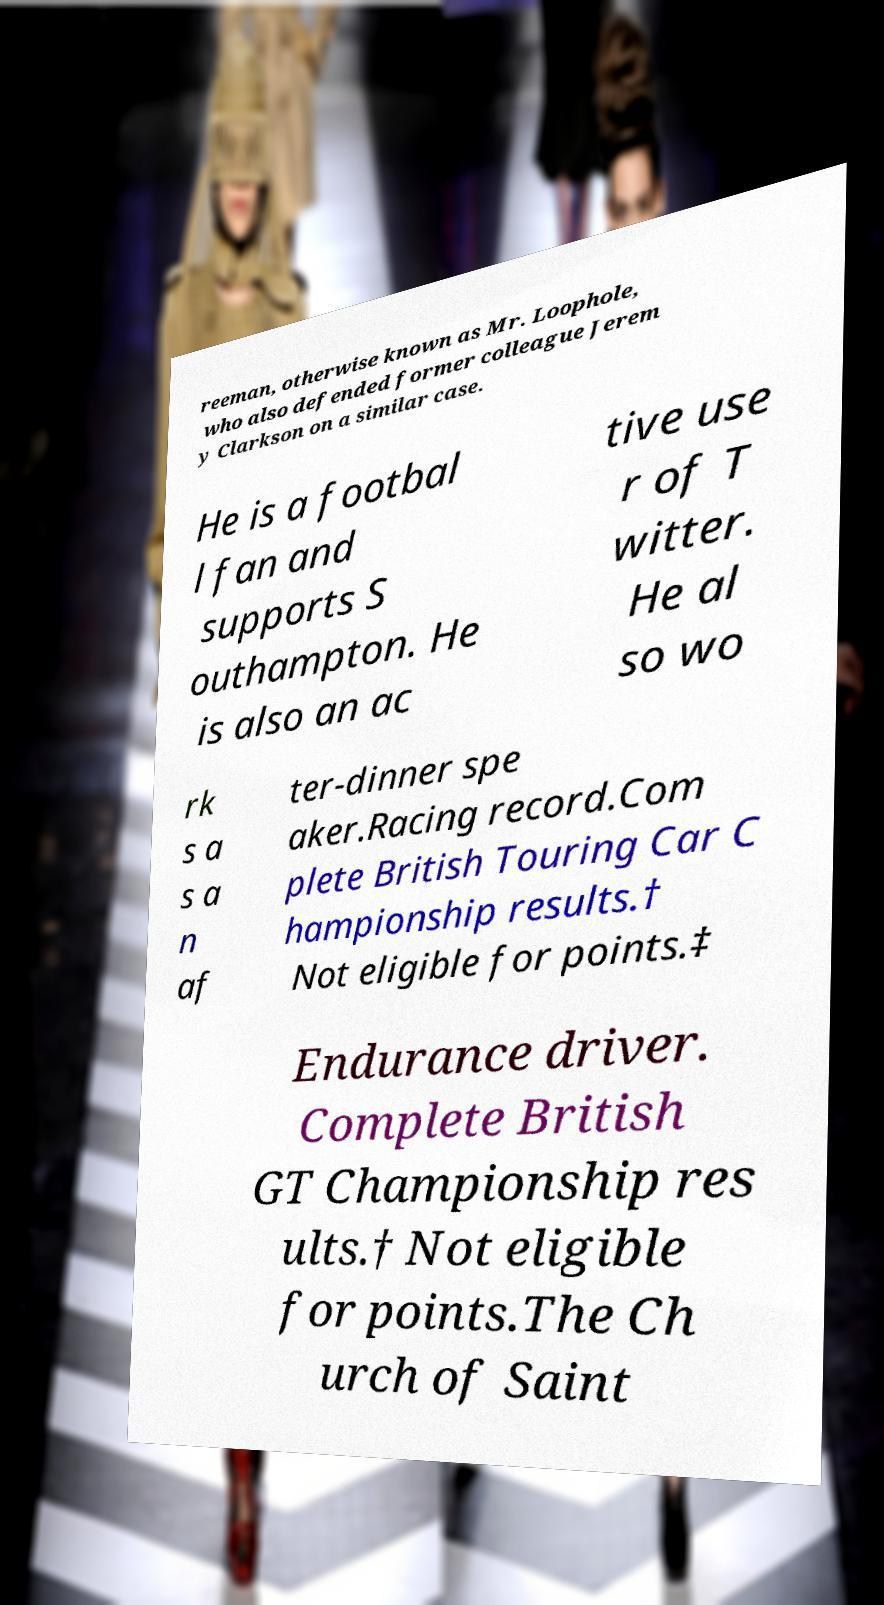For documentation purposes, I need the text within this image transcribed. Could you provide that? reeman, otherwise known as Mr. Loophole, who also defended former colleague Jerem y Clarkson on a similar case. He is a footbal l fan and supports S outhampton. He is also an ac tive use r of T witter. He al so wo rk s a s a n af ter-dinner spe aker.Racing record.Com plete British Touring Car C hampionship results.† Not eligible for points.‡ Endurance driver. Complete British GT Championship res ults.† Not eligible for points.The Ch urch of Saint 